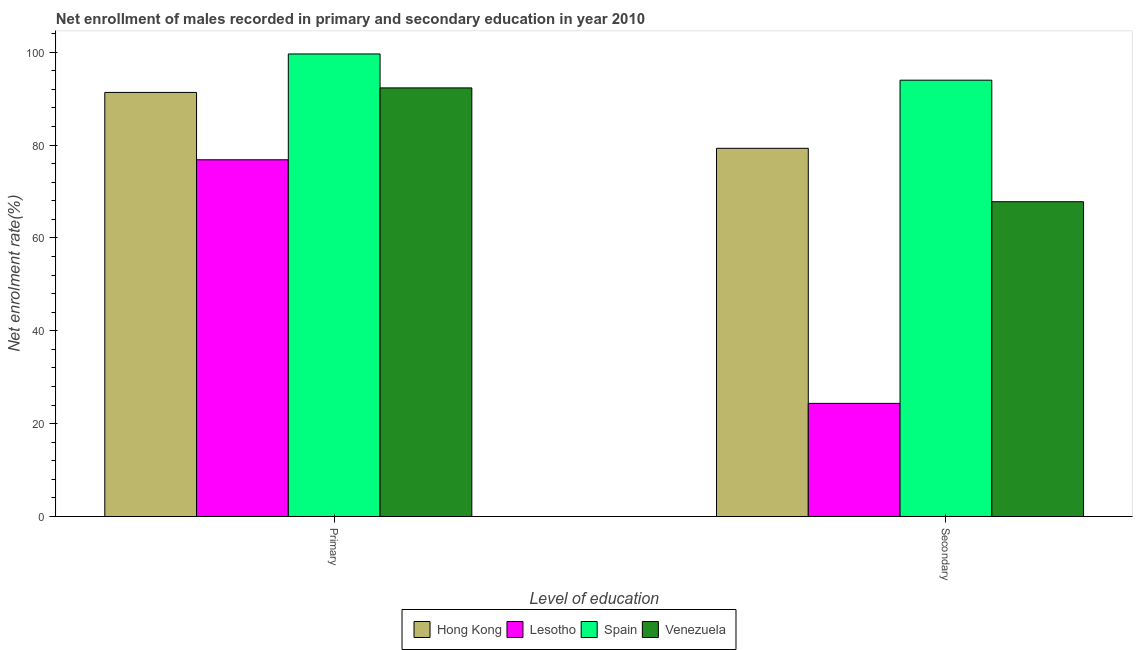How many different coloured bars are there?
Ensure brevity in your answer.  4. Are the number of bars on each tick of the X-axis equal?
Offer a terse response. Yes. How many bars are there on the 1st tick from the left?
Provide a succinct answer. 4. What is the label of the 1st group of bars from the left?
Provide a short and direct response. Primary. What is the enrollment rate in primary education in Spain?
Provide a succinct answer. 99.62. Across all countries, what is the maximum enrollment rate in primary education?
Your answer should be compact. 99.62. Across all countries, what is the minimum enrollment rate in primary education?
Give a very brief answer. 76.83. In which country was the enrollment rate in secondary education maximum?
Your answer should be very brief. Spain. In which country was the enrollment rate in primary education minimum?
Keep it short and to the point. Lesotho. What is the total enrollment rate in secondary education in the graph?
Provide a short and direct response. 265.44. What is the difference between the enrollment rate in secondary education in Hong Kong and that in Venezuela?
Offer a terse response. 11.5. What is the difference between the enrollment rate in secondary education in Spain and the enrollment rate in primary education in Hong Kong?
Offer a very short reply. 2.64. What is the average enrollment rate in primary education per country?
Your answer should be very brief. 90.02. What is the difference between the enrollment rate in secondary education and enrollment rate in primary education in Hong Kong?
Ensure brevity in your answer.  -12.04. What is the ratio of the enrollment rate in primary education in Spain to that in Lesotho?
Provide a succinct answer. 1.3. Is the enrollment rate in secondary education in Venezuela less than that in Spain?
Your answer should be very brief. Yes. In how many countries, is the enrollment rate in secondary education greater than the average enrollment rate in secondary education taken over all countries?
Offer a very short reply. 3. What does the 3rd bar from the left in Primary represents?
Keep it short and to the point. Spain. What does the 4th bar from the right in Primary represents?
Give a very brief answer. Hong Kong. Are all the bars in the graph horizontal?
Your answer should be compact. No. How many countries are there in the graph?
Your answer should be compact. 4. How many legend labels are there?
Your response must be concise. 4. How are the legend labels stacked?
Offer a very short reply. Horizontal. What is the title of the graph?
Offer a terse response. Net enrollment of males recorded in primary and secondary education in year 2010. What is the label or title of the X-axis?
Keep it short and to the point. Level of education. What is the label or title of the Y-axis?
Offer a terse response. Net enrolment rate(%). What is the Net enrolment rate(%) in Hong Kong in Primary?
Give a very brief answer. 91.34. What is the Net enrolment rate(%) in Lesotho in Primary?
Your response must be concise. 76.83. What is the Net enrolment rate(%) of Spain in Primary?
Provide a succinct answer. 99.62. What is the Net enrolment rate(%) of Venezuela in Primary?
Make the answer very short. 92.31. What is the Net enrolment rate(%) of Hong Kong in Secondary?
Offer a terse response. 79.3. What is the Net enrolment rate(%) of Lesotho in Secondary?
Your response must be concise. 24.36. What is the Net enrolment rate(%) in Spain in Secondary?
Make the answer very short. 93.97. What is the Net enrolment rate(%) of Venezuela in Secondary?
Make the answer very short. 67.8. Across all Level of education, what is the maximum Net enrolment rate(%) of Hong Kong?
Make the answer very short. 91.34. Across all Level of education, what is the maximum Net enrolment rate(%) in Lesotho?
Provide a succinct answer. 76.83. Across all Level of education, what is the maximum Net enrolment rate(%) of Spain?
Give a very brief answer. 99.62. Across all Level of education, what is the maximum Net enrolment rate(%) of Venezuela?
Your response must be concise. 92.31. Across all Level of education, what is the minimum Net enrolment rate(%) in Hong Kong?
Provide a short and direct response. 79.3. Across all Level of education, what is the minimum Net enrolment rate(%) in Lesotho?
Offer a terse response. 24.36. Across all Level of education, what is the minimum Net enrolment rate(%) of Spain?
Your response must be concise. 93.97. Across all Level of education, what is the minimum Net enrolment rate(%) in Venezuela?
Keep it short and to the point. 67.8. What is the total Net enrolment rate(%) of Hong Kong in the graph?
Your answer should be very brief. 170.64. What is the total Net enrolment rate(%) in Lesotho in the graph?
Offer a terse response. 101.19. What is the total Net enrolment rate(%) in Spain in the graph?
Provide a short and direct response. 193.59. What is the total Net enrolment rate(%) of Venezuela in the graph?
Provide a short and direct response. 160.11. What is the difference between the Net enrolment rate(%) in Hong Kong in Primary and that in Secondary?
Offer a terse response. 12.04. What is the difference between the Net enrolment rate(%) of Lesotho in Primary and that in Secondary?
Provide a short and direct response. 52.46. What is the difference between the Net enrolment rate(%) in Spain in Primary and that in Secondary?
Provide a short and direct response. 5.65. What is the difference between the Net enrolment rate(%) in Venezuela in Primary and that in Secondary?
Provide a short and direct response. 24.51. What is the difference between the Net enrolment rate(%) in Hong Kong in Primary and the Net enrolment rate(%) in Lesotho in Secondary?
Make the answer very short. 66.97. What is the difference between the Net enrolment rate(%) in Hong Kong in Primary and the Net enrolment rate(%) in Spain in Secondary?
Your answer should be compact. -2.64. What is the difference between the Net enrolment rate(%) of Hong Kong in Primary and the Net enrolment rate(%) of Venezuela in Secondary?
Provide a succinct answer. 23.54. What is the difference between the Net enrolment rate(%) in Lesotho in Primary and the Net enrolment rate(%) in Spain in Secondary?
Provide a short and direct response. -17.14. What is the difference between the Net enrolment rate(%) in Lesotho in Primary and the Net enrolment rate(%) in Venezuela in Secondary?
Make the answer very short. 9.03. What is the difference between the Net enrolment rate(%) in Spain in Primary and the Net enrolment rate(%) in Venezuela in Secondary?
Provide a short and direct response. 31.82. What is the average Net enrolment rate(%) in Hong Kong per Level of education?
Your answer should be compact. 85.32. What is the average Net enrolment rate(%) of Lesotho per Level of education?
Your answer should be very brief. 50.6. What is the average Net enrolment rate(%) in Spain per Level of education?
Your answer should be very brief. 96.8. What is the average Net enrolment rate(%) of Venezuela per Level of education?
Your answer should be compact. 80.05. What is the difference between the Net enrolment rate(%) of Hong Kong and Net enrolment rate(%) of Lesotho in Primary?
Make the answer very short. 14.51. What is the difference between the Net enrolment rate(%) of Hong Kong and Net enrolment rate(%) of Spain in Primary?
Your answer should be very brief. -8.29. What is the difference between the Net enrolment rate(%) in Hong Kong and Net enrolment rate(%) in Venezuela in Primary?
Offer a terse response. -0.97. What is the difference between the Net enrolment rate(%) in Lesotho and Net enrolment rate(%) in Spain in Primary?
Give a very brief answer. -22.79. What is the difference between the Net enrolment rate(%) in Lesotho and Net enrolment rate(%) in Venezuela in Primary?
Keep it short and to the point. -15.48. What is the difference between the Net enrolment rate(%) of Spain and Net enrolment rate(%) of Venezuela in Primary?
Offer a terse response. 7.31. What is the difference between the Net enrolment rate(%) in Hong Kong and Net enrolment rate(%) in Lesotho in Secondary?
Your answer should be compact. 54.94. What is the difference between the Net enrolment rate(%) of Hong Kong and Net enrolment rate(%) of Spain in Secondary?
Provide a short and direct response. -14.67. What is the difference between the Net enrolment rate(%) in Hong Kong and Net enrolment rate(%) in Venezuela in Secondary?
Offer a very short reply. 11.5. What is the difference between the Net enrolment rate(%) of Lesotho and Net enrolment rate(%) of Spain in Secondary?
Your response must be concise. -69.61. What is the difference between the Net enrolment rate(%) in Lesotho and Net enrolment rate(%) in Venezuela in Secondary?
Your answer should be very brief. -43.43. What is the difference between the Net enrolment rate(%) in Spain and Net enrolment rate(%) in Venezuela in Secondary?
Make the answer very short. 26.17. What is the ratio of the Net enrolment rate(%) of Hong Kong in Primary to that in Secondary?
Keep it short and to the point. 1.15. What is the ratio of the Net enrolment rate(%) in Lesotho in Primary to that in Secondary?
Provide a succinct answer. 3.15. What is the ratio of the Net enrolment rate(%) of Spain in Primary to that in Secondary?
Your answer should be very brief. 1.06. What is the ratio of the Net enrolment rate(%) of Venezuela in Primary to that in Secondary?
Your answer should be very brief. 1.36. What is the difference between the highest and the second highest Net enrolment rate(%) in Hong Kong?
Your answer should be compact. 12.04. What is the difference between the highest and the second highest Net enrolment rate(%) in Lesotho?
Provide a succinct answer. 52.46. What is the difference between the highest and the second highest Net enrolment rate(%) of Spain?
Give a very brief answer. 5.65. What is the difference between the highest and the second highest Net enrolment rate(%) in Venezuela?
Offer a terse response. 24.51. What is the difference between the highest and the lowest Net enrolment rate(%) in Hong Kong?
Provide a succinct answer. 12.04. What is the difference between the highest and the lowest Net enrolment rate(%) of Lesotho?
Provide a short and direct response. 52.46. What is the difference between the highest and the lowest Net enrolment rate(%) of Spain?
Give a very brief answer. 5.65. What is the difference between the highest and the lowest Net enrolment rate(%) of Venezuela?
Your answer should be compact. 24.51. 